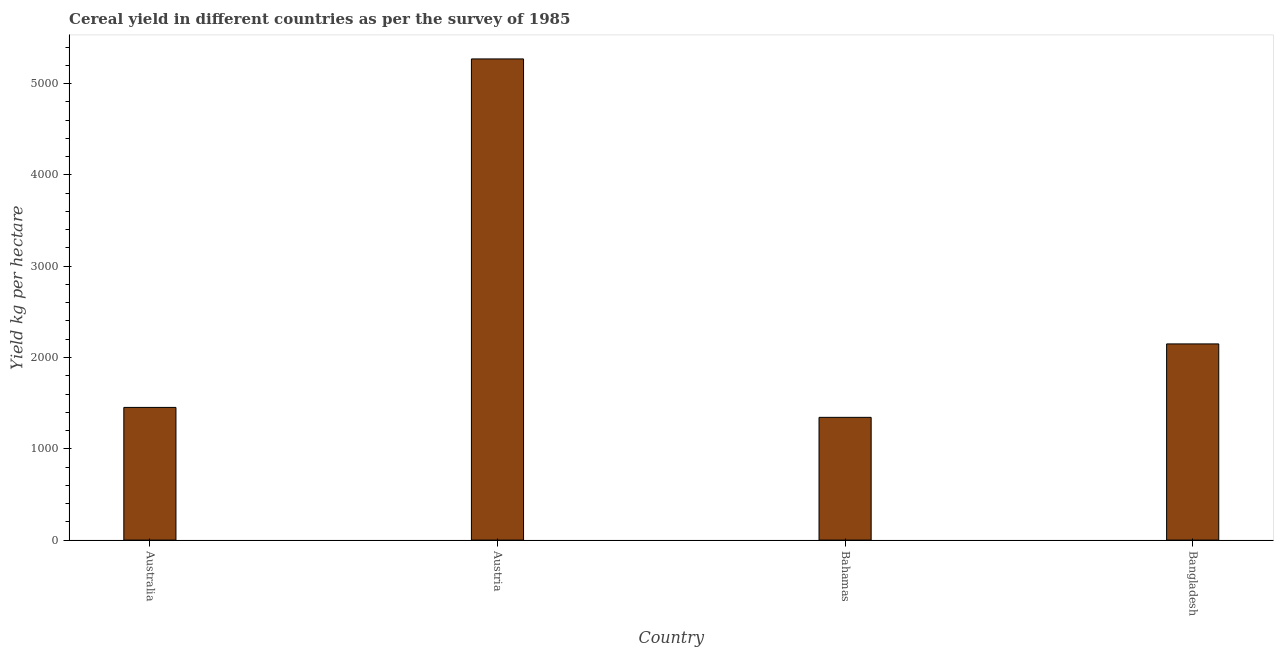Does the graph contain grids?
Your answer should be compact. No. What is the title of the graph?
Ensure brevity in your answer.  Cereal yield in different countries as per the survey of 1985. What is the label or title of the X-axis?
Offer a terse response. Country. What is the label or title of the Y-axis?
Your answer should be compact. Yield kg per hectare. What is the cereal yield in Bahamas?
Provide a short and direct response. 1344.26. Across all countries, what is the maximum cereal yield?
Make the answer very short. 5269.44. Across all countries, what is the minimum cereal yield?
Offer a terse response. 1344.26. In which country was the cereal yield minimum?
Keep it short and to the point. Bahamas. What is the sum of the cereal yield?
Offer a terse response. 1.02e+04. What is the difference between the cereal yield in Australia and Austria?
Make the answer very short. -3816.37. What is the average cereal yield per country?
Provide a short and direct response. 2553.83. What is the median cereal yield?
Your answer should be compact. 1800.81. In how many countries, is the cereal yield greater than 3000 kg per hectare?
Offer a very short reply. 1. What is the ratio of the cereal yield in Austria to that in Bahamas?
Offer a terse response. 3.92. Is the cereal yield in Austria less than that in Bangladesh?
Your response must be concise. No. Is the difference between the cereal yield in Austria and Bangladesh greater than the difference between any two countries?
Provide a succinct answer. No. What is the difference between the highest and the second highest cereal yield?
Provide a short and direct response. 3120.9. What is the difference between the highest and the lowest cereal yield?
Your answer should be very brief. 3925.18. How many bars are there?
Ensure brevity in your answer.  4. Are all the bars in the graph horizontal?
Make the answer very short. No. What is the difference between two consecutive major ticks on the Y-axis?
Offer a very short reply. 1000. What is the Yield kg per hectare of Australia?
Offer a terse response. 1453.07. What is the Yield kg per hectare of Austria?
Ensure brevity in your answer.  5269.44. What is the Yield kg per hectare of Bahamas?
Offer a very short reply. 1344.26. What is the Yield kg per hectare in Bangladesh?
Your response must be concise. 2148.54. What is the difference between the Yield kg per hectare in Australia and Austria?
Your answer should be compact. -3816.37. What is the difference between the Yield kg per hectare in Australia and Bahamas?
Offer a very short reply. 108.81. What is the difference between the Yield kg per hectare in Australia and Bangladesh?
Offer a very short reply. -695.47. What is the difference between the Yield kg per hectare in Austria and Bahamas?
Provide a succinct answer. 3925.18. What is the difference between the Yield kg per hectare in Austria and Bangladesh?
Your response must be concise. 3120.9. What is the difference between the Yield kg per hectare in Bahamas and Bangladesh?
Give a very brief answer. -804.28. What is the ratio of the Yield kg per hectare in Australia to that in Austria?
Provide a succinct answer. 0.28. What is the ratio of the Yield kg per hectare in Australia to that in Bahamas?
Give a very brief answer. 1.08. What is the ratio of the Yield kg per hectare in Australia to that in Bangladesh?
Keep it short and to the point. 0.68. What is the ratio of the Yield kg per hectare in Austria to that in Bahamas?
Offer a terse response. 3.92. What is the ratio of the Yield kg per hectare in Austria to that in Bangladesh?
Offer a very short reply. 2.45. What is the ratio of the Yield kg per hectare in Bahamas to that in Bangladesh?
Your answer should be compact. 0.63. 